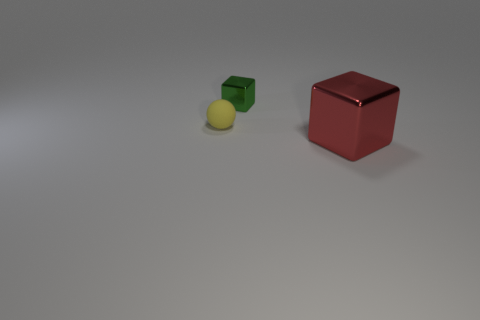Add 2 big cubes. How many objects exist? 5 Subtract all cubes. How many objects are left? 1 Subtract all green metallic things. Subtract all blue rubber things. How many objects are left? 2 Add 3 tiny metallic blocks. How many tiny metallic blocks are left? 4 Add 1 purple rubber cylinders. How many purple rubber cylinders exist? 1 Subtract 1 green cubes. How many objects are left? 2 